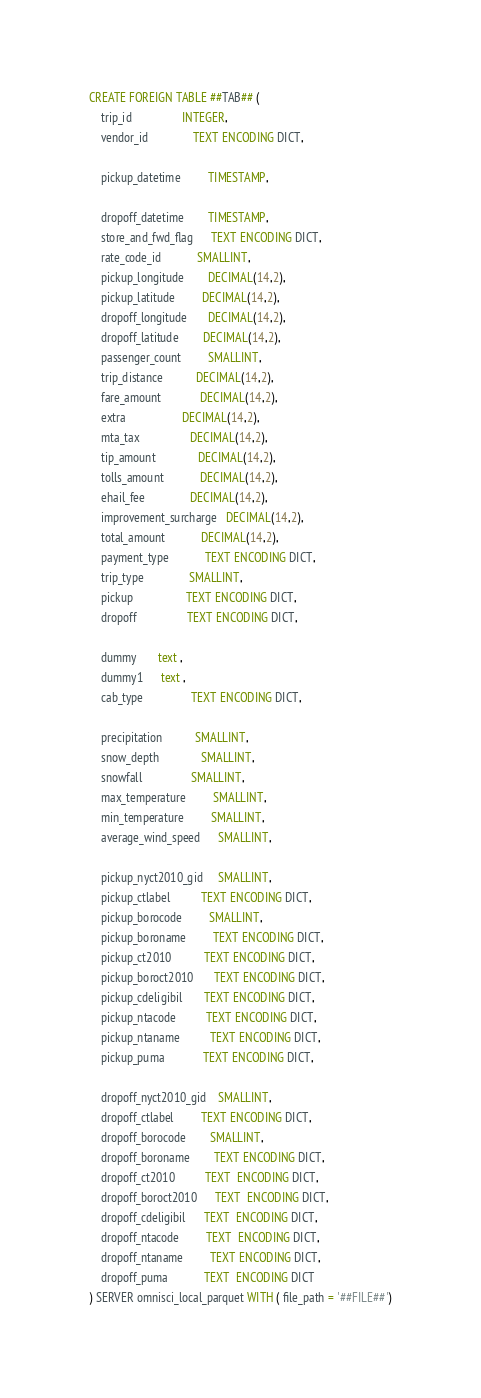Convert code to text. <code><loc_0><loc_0><loc_500><loc_500><_SQL_>CREATE FOREIGN TABLE ##TAB## (
    trip_id                 INTEGER,
    vendor_id               TEXT ENCODING DICT,

    pickup_datetime         TIMESTAMP,

    dropoff_datetime        TIMESTAMP,
    store_and_fwd_flag      TEXT ENCODING DICT,
    rate_code_id            SMALLINT,
    pickup_longitude        DECIMAL(14,2),
    pickup_latitude         DECIMAL(14,2),
    dropoff_longitude       DECIMAL(14,2),
    dropoff_latitude        DECIMAL(14,2),
    passenger_count         SMALLINT,
    trip_distance           DECIMAL(14,2),
    fare_amount             DECIMAL(14,2),
    extra                   DECIMAL(14,2),
    mta_tax                 DECIMAL(14,2),
    tip_amount              DECIMAL(14,2),
    tolls_amount            DECIMAL(14,2),
    ehail_fee               DECIMAL(14,2),
    improvement_surcharge   DECIMAL(14,2),
    total_amount            DECIMAL(14,2),
    payment_type            TEXT ENCODING DICT,
    trip_type               SMALLINT,
    pickup                  TEXT ENCODING DICT,
    dropoff                 TEXT ENCODING DICT,

    dummy       text ,
    dummy1      text ,
    cab_type                TEXT ENCODING DICT,

    precipitation           SMALLINT,
    snow_depth              SMALLINT,
    snowfall                SMALLINT,
    max_temperature         SMALLINT,
    min_temperature         SMALLINT,
    average_wind_speed      SMALLINT,

    pickup_nyct2010_gid     SMALLINT,
    pickup_ctlabel          TEXT ENCODING DICT,
    pickup_borocode         SMALLINT,
    pickup_boroname         TEXT ENCODING DICT,
    pickup_ct2010           TEXT ENCODING DICT,
    pickup_boroct2010       TEXT ENCODING DICT,
    pickup_cdeligibil       TEXT ENCODING DICT,
    pickup_ntacode          TEXT ENCODING DICT,
    pickup_ntaname          TEXT ENCODING DICT,
    pickup_puma             TEXT ENCODING DICT,

    dropoff_nyct2010_gid    SMALLINT,
    dropoff_ctlabel         TEXT ENCODING DICT,
    dropoff_borocode        SMALLINT,
    dropoff_boroname        TEXT ENCODING DICT,
    dropoff_ct2010          TEXT  ENCODING DICT,
    dropoff_boroct2010      TEXT  ENCODING DICT,
    dropoff_cdeligibil      TEXT  ENCODING DICT,
    dropoff_ntacode         TEXT  ENCODING DICT,
    dropoff_ntaname         TEXT ENCODING DICT,
    dropoff_puma            TEXT  ENCODING DICT
) SERVER omnisci_local_parquet WITH ( file_path = '##FILE##')
</code> 